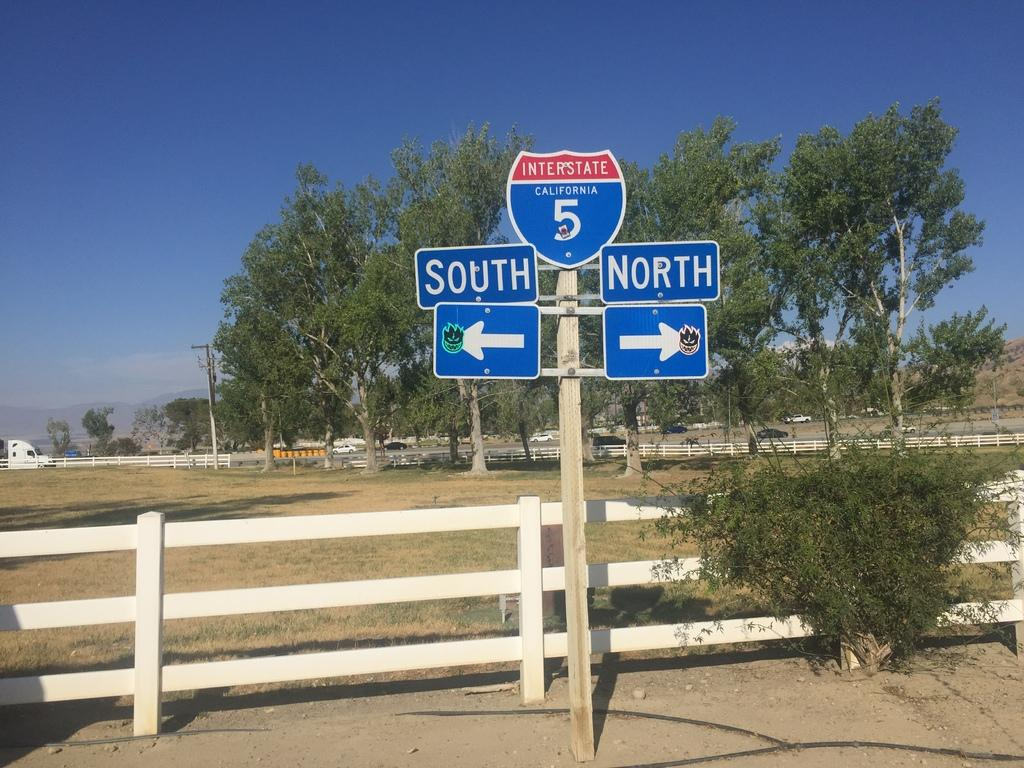<image>
Create a compact narrative representing the image presented. A sign for route five with a white fence behind it. 